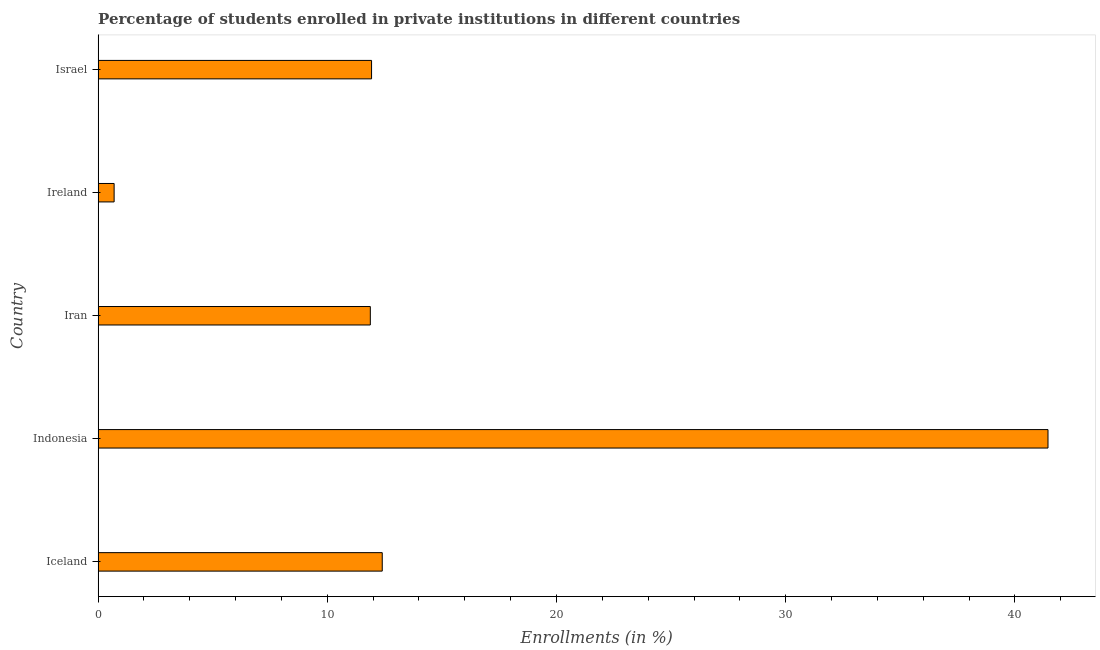Does the graph contain any zero values?
Offer a very short reply. No. Does the graph contain grids?
Offer a very short reply. No. What is the title of the graph?
Provide a succinct answer. Percentage of students enrolled in private institutions in different countries. What is the label or title of the X-axis?
Ensure brevity in your answer.  Enrollments (in %). What is the enrollments in private institutions in Ireland?
Offer a very short reply. 0.7. Across all countries, what is the maximum enrollments in private institutions?
Ensure brevity in your answer.  41.45. Across all countries, what is the minimum enrollments in private institutions?
Your answer should be compact. 0.7. In which country was the enrollments in private institutions maximum?
Provide a short and direct response. Indonesia. In which country was the enrollments in private institutions minimum?
Give a very brief answer. Ireland. What is the sum of the enrollments in private institutions?
Offer a very short reply. 78.35. What is the difference between the enrollments in private institutions in Iceland and Iran?
Your answer should be compact. 0.52. What is the average enrollments in private institutions per country?
Offer a terse response. 15.67. What is the median enrollments in private institutions?
Provide a succinct answer. 11.93. What is the ratio of the enrollments in private institutions in Iceland to that in Iran?
Make the answer very short. 1.04. What is the difference between the highest and the second highest enrollments in private institutions?
Your response must be concise. 29.05. Is the sum of the enrollments in private institutions in Iran and Ireland greater than the maximum enrollments in private institutions across all countries?
Ensure brevity in your answer.  No. What is the difference between the highest and the lowest enrollments in private institutions?
Your answer should be very brief. 40.75. How many bars are there?
Your answer should be compact. 5. Are all the bars in the graph horizontal?
Provide a succinct answer. Yes. What is the Enrollments (in %) in Iceland?
Give a very brief answer. 12.4. What is the Enrollments (in %) in Indonesia?
Provide a succinct answer. 41.45. What is the Enrollments (in %) in Iran?
Your answer should be compact. 11.88. What is the Enrollments (in %) of Ireland?
Offer a very short reply. 0.7. What is the Enrollments (in %) of Israel?
Your response must be concise. 11.93. What is the difference between the Enrollments (in %) in Iceland and Indonesia?
Keep it short and to the point. -29.05. What is the difference between the Enrollments (in %) in Iceland and Iran?
Provide a short and direct response. 0.52. What is the difference between the Enrollments (in %) in Iceland and Ireland?
Provide a short and direct response. 11.7. What is the difference between the Enrollments (in %) in Iceland and Israel?
Ensure brevity in your answer.  0.47. What is the difference between the Enrollments (in %) in Indonesia and Iran?
Provide a succinct answer. 29.57. What is the difference between the Enrollments (in %) in Indonesia and Ireland?
Make the answer very short. 40.75. What is the difference between the Enrollments (in %) in Indonesia and Israel?
Your answer should be very brief. 29.51. What is the difference between the Enrollments (in %) in Iran and Ireland?
Provide a succinct answer. 11.18. What is the difference between the Enrollments (in %) in Iran and Israel?
Provide a short and direct response. -0.05. What is the difference between the Enrollments (in %) in Ireland and Israel?
Offer a terse response. -11.23. What is the ratio of the Enrollments (in %) in Iceland to that in Indonesia?
Offer a very short reply. 0.3. What is the ratio of the Enrollments (in %) in Iceland to that in Iran?
Provide a succinct answer. 1.04. What is the ratio of the Enrollments (in %) in Iceland to that in Ireland?
Your answer should be compact. 17.75. What is the ratio of the Enrollments (in %) in Iceland to that in Israel?
Keep it short and to the point. 1.04. What is the ratio of the Enrollments (in %) in Indonesia to that in Iran?
Provide a succinct answer. 3.49. What is the ratio of the Enrollments (in %) in Indonesia to that in Ireland?
Your answer should be compact. 59.34. What is the ratio of the Enrollments (in %) in Indonesia to that in Israel?
Offer a terse response. 3.47. What is the ratio of the Enrollments (in %) in Iran to that in Ireland?
Your response must be concise. 17.01. What is the ratio of the Enrollments (in %) in Ireland to that in Israel?
Make the answer very short. 0.06. 